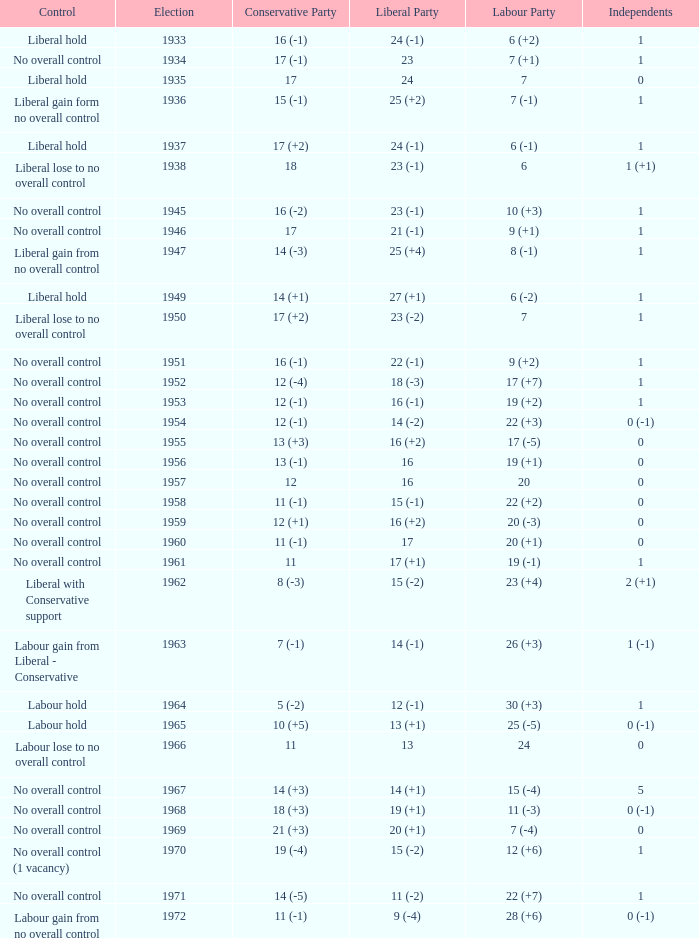What was the control for the year with a Conservative Party result of 10 (+5)? Labour hold. 